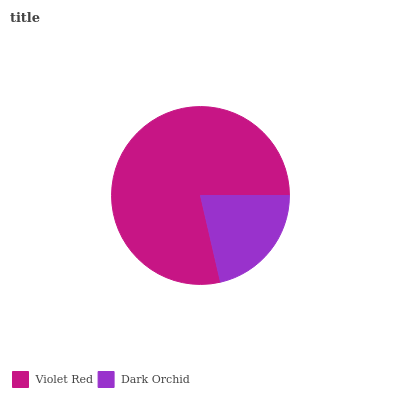Is Dark Orchid the minimum?
Answer yes or no. Yes. Is Violet Red the maximum?
Answer yes or no. Yes. Is Dark Orchid the maximum?
Answer yes or no. No. Is Violet Red greater than Dark Orchid?
Answer yes or no. Yes. Is Dark Orchid less than Violet Red?
Answer yes or no. Yes. Is Dark Orchid greater than Violet Red?
Answer yes or no. No. Is Violet Red less than Dark Orchid?
Answer yes or no. No. Is Violet Red the high median?
Answer yes or no. Yes. Is Dark Orchid the low median?
Answer yes or no. Yes. Is Dark Orchid the high median?
Answer yes or no. No. Is Violet Red the low median?
Answer yes or no. No. 